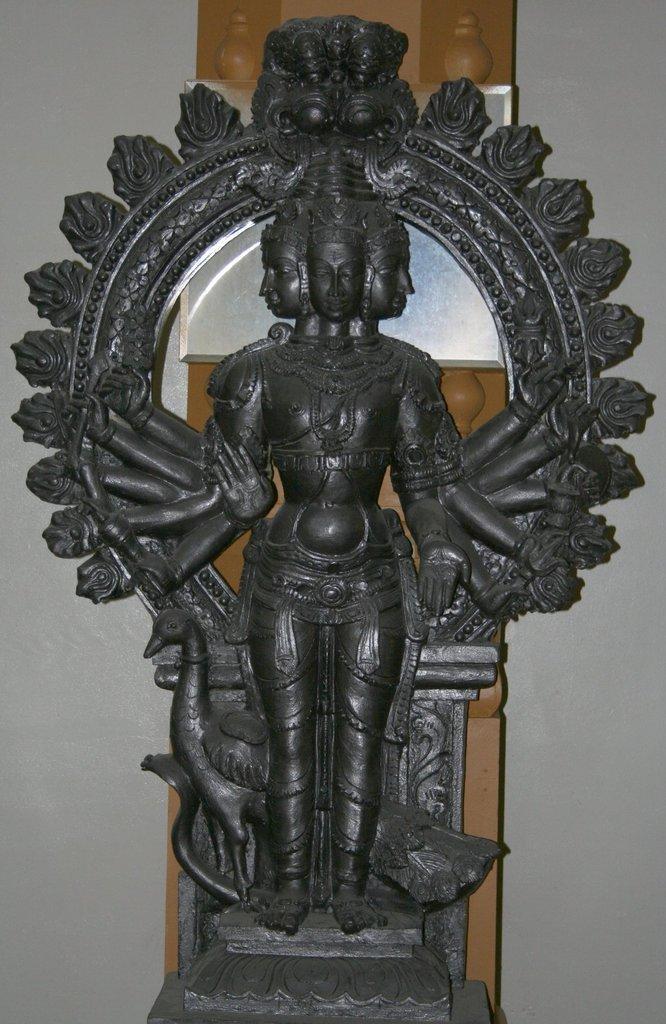Can you describe this image briefly? In this picture we can see a statue and in the background we can see some objects and the wall. 